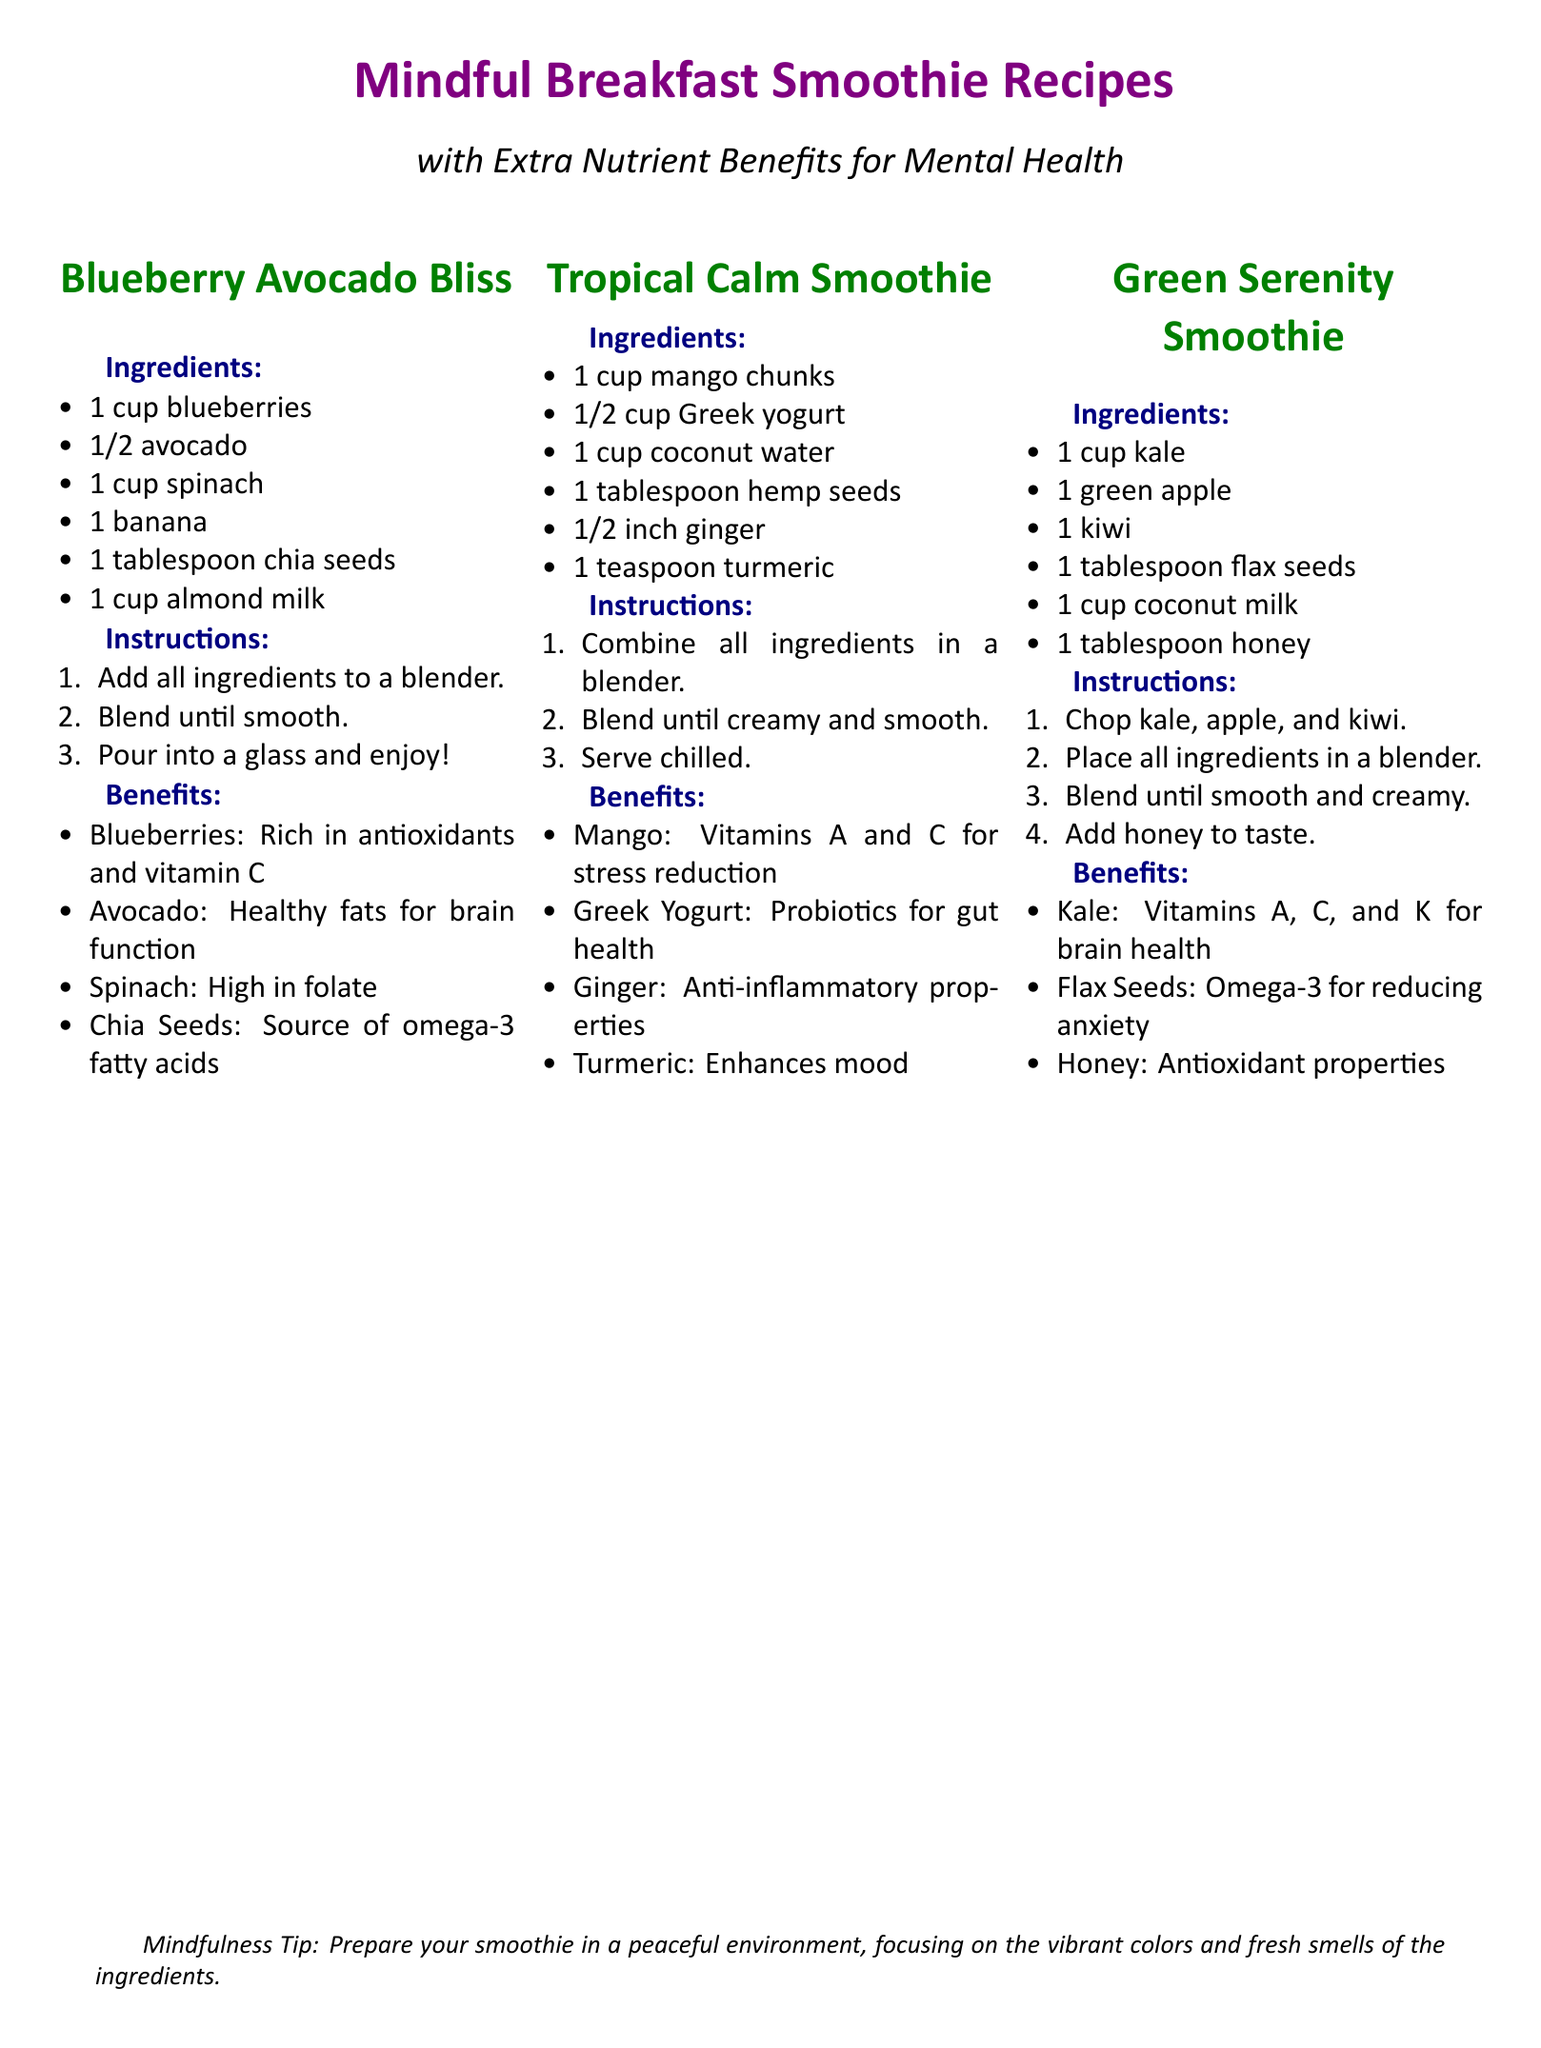What is the title of the first smoothie recipe? The title can be found at the beginning of the recipe section, which is "Blueberry Avocado Bliss."
Answer: Blueberry Avocado Bliss How many ingredients are listed for the Tropical Calm Smoothie? The number of ingredients can be counted in the Tropical Calm Smoothie section, which lists six ingredients.
Answer: 6 What is one of the benefits of consuming chia seeds? The benefits of chia seeds are described in the recipe benefits section, indicating they are a source of omega-3 fatty acids.
Answer: Omega-3 fatty acids Which ingredient is suggested for gut health in the Tropical Calm Smoothie? The ingredient related to gut health is mentioned under the benefits of the Tropical Calm Smoothie, which includes Greek yogurt.
Answer: Greek yogurt What is a mindfulness tip mentioned in the document? The mindfulness tip is located at the bottom of the document and suggests to prepare the smoothie in a peaceful environment.
Answer: Prepare your smoothie in a peaceful environment What type of milk is used in the Green Serenity Smoothie? The type of milk used in the Green Serenity Smoothie can be found in the ingredients list, which states coconut milk.
Answer: Coconut milk What green vegetable is used in the Blueberry Avocado Bliss smoothie? The green vegetable can be located in the ingredients of the Blueberry Avocado Bliss recipe, which includes spinach.
Answer: Spinach Which fruit is emphasized for its stress reduction properties in the Tropical Calm Smoothie? The fruit associated with stress reduction benefits is mentioned in the recipe benefits section as mango.
Answer: Mango 